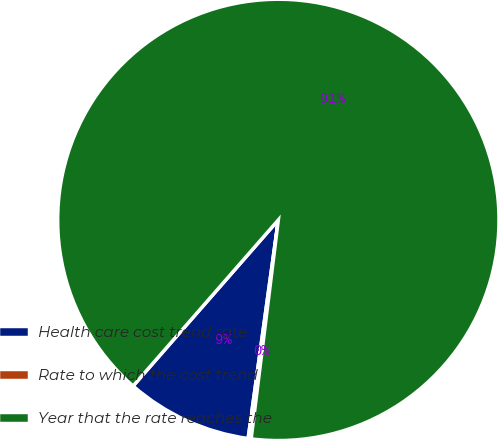Convert chart. <chart><loc_0><loc_0><loc_500><loc_500><pie_chart><fcel>Health care cost trend rate<fcel>Rate to which the cost trend<fcel>Year that the rate reaches the<nl><fcel>9.25%<fcel>0.22%<fcel>90.52%<nl></chart> 